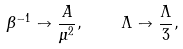Convert formula to latex. <formula><loc_0><loc_0><loc_500><loc_500>\beta ^ { - 1 } \to \frac { A } { \mu ^ { 2 } } , \quad \Lambda \to \frac { \Lambda } { 3 } ,</formula> 